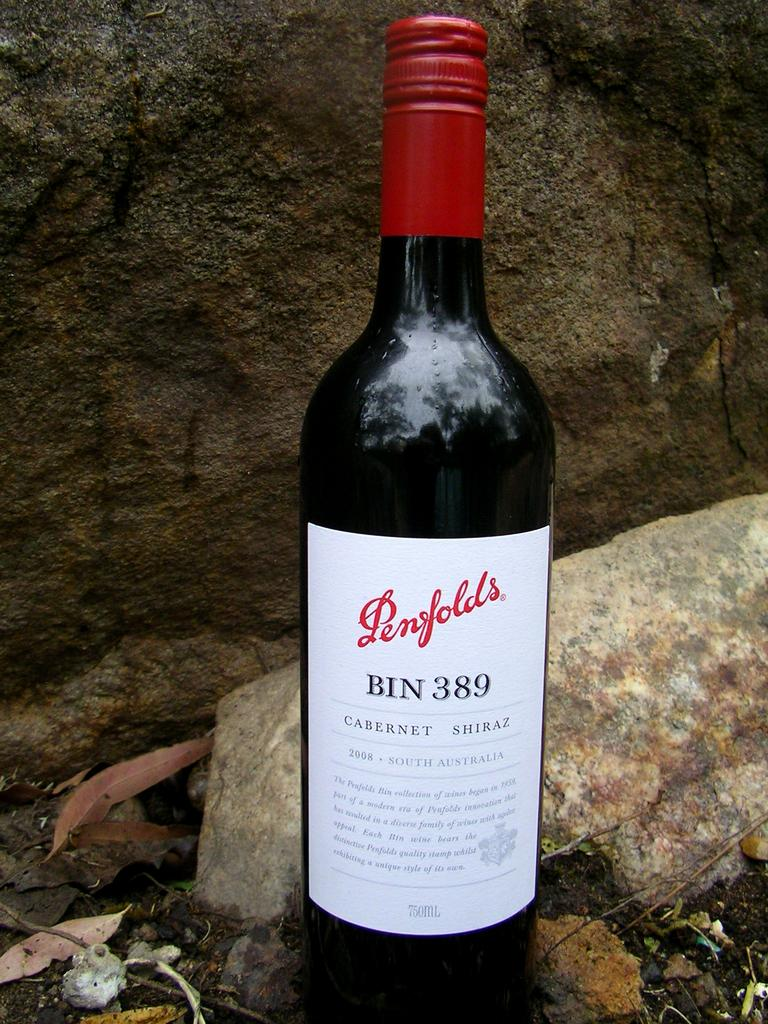What can be seen in the image? There is a bottle in the image. What is unique about the bottle? The bottle has a label. What is visible in the background of the image? There are rocks behind the bottle. What type of liquid is inside the bottle in the image? The image does not provide information about the contents of the bottle, so it cannot be determined if there is any liquid inside. 